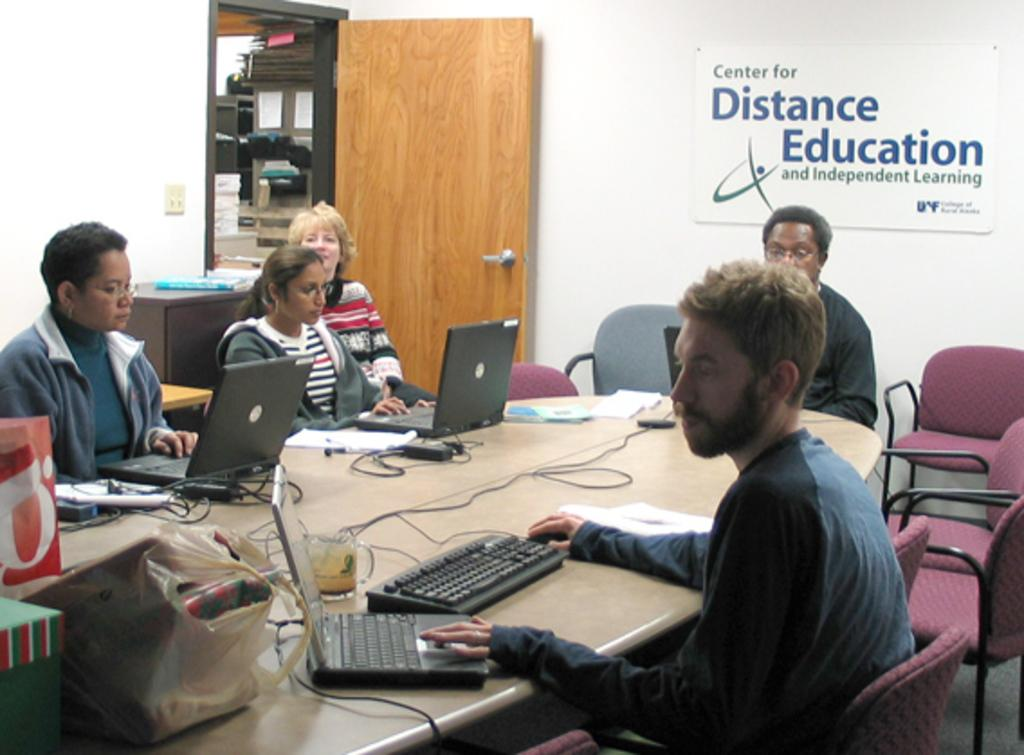<image>
Describe the image concisely. People in a conference room with a sign reading Center for Distance Education 